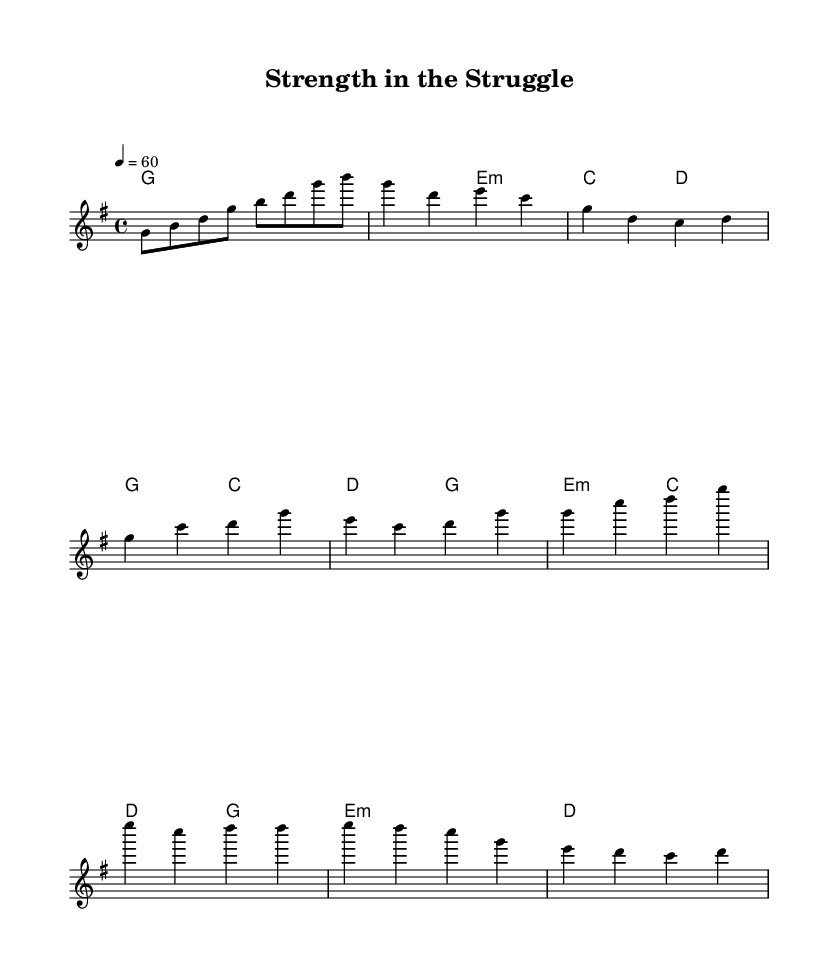What is the key signature of this music? The key signature is G major, which has one sharp (F#). This can be identified by looking at the key signature indicated at the beginning of the sheet music.
Answer: G major What is the time signature of this music? The time signature is 4/4, which means there are four beats in each measure, and a quarter note receives one beat. This is observed at the beginning of the sheet music right after the key signature.
Answer: 4/4 What is the tempo marking indicated in the music? The tempo marking is quarter note equals 60, which indicates a slow tempo. This can be found at the top of the sheet music in the tempo section.
Answer: 60 How many measures are there in the chorus section? The chorus section consists of four measures. This is determined by counting the measures in the specified chorus lines within the melody.
Answer: 4 What is the first chord in the piece? The first chord is G major. This is indicated in the harmonies section, where the first chord is shown at the start of the music.
Answer: G major Which minor chord is used in the chorus? The minor chord used in the chorus is E minor. This is identified by looking at the chord progression in the chorus section where E minor is specified.
Answer: E minor What major scale does this ballad primarily emphasize? The ballad primarily emphasizes G major scale. This is inferred from the key signature and chords used throughout the piece, which align with the G major scale.
Answer: G major 